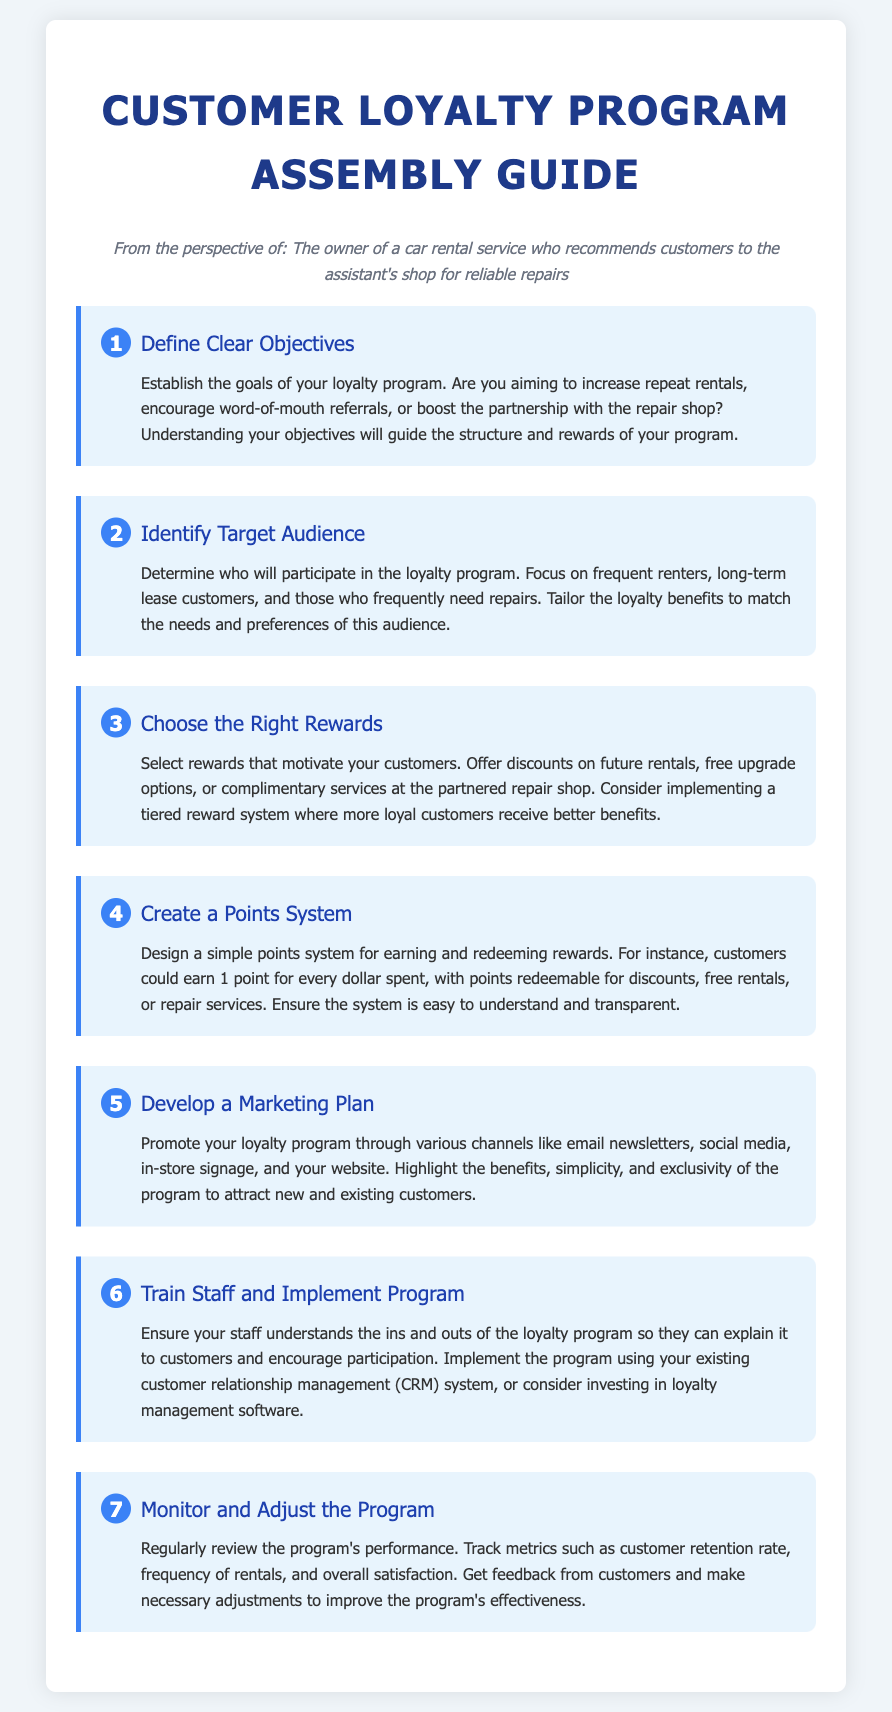What is the first step in assembling a Customer Loyalty Program? The first step is to define clear objectives for the loyalty program.
Answer: Define Clear Objectives How many steps are included in the guide? The guide includes a total of seven steps.
Answer: 7 What type of rewards can be offered according to step three? Step three mentions offering discounts, free upgrades, or complimentary services as potential rewards.
Answer: Discounts, free upgrades, or complimentary services Who should be the target audience identified in step two? Step two suggests focusing on frequent renters, long-term lease customers, and those needing repairs.
Answer: Frequent renters, long-term lease customers, and those needing repairs What is the purpose of developing a marketing plan in step five? The purpose is to promote the loyalty program and highlight its benefits to attract customers.
Answer: Promote the loyalty program What system should be used to implement the program as per step six? The program should be implemented using an existing customer relationship management (CRM) system.
Answer: Customer relationship management (CRM) system What should be monitored according to the last step? The last step advises monitoring customer retention rate, frequency of rentals, and overall satisfaction.
Answer: Customer retention rate, frequency of rentals, and overall satisfaction 